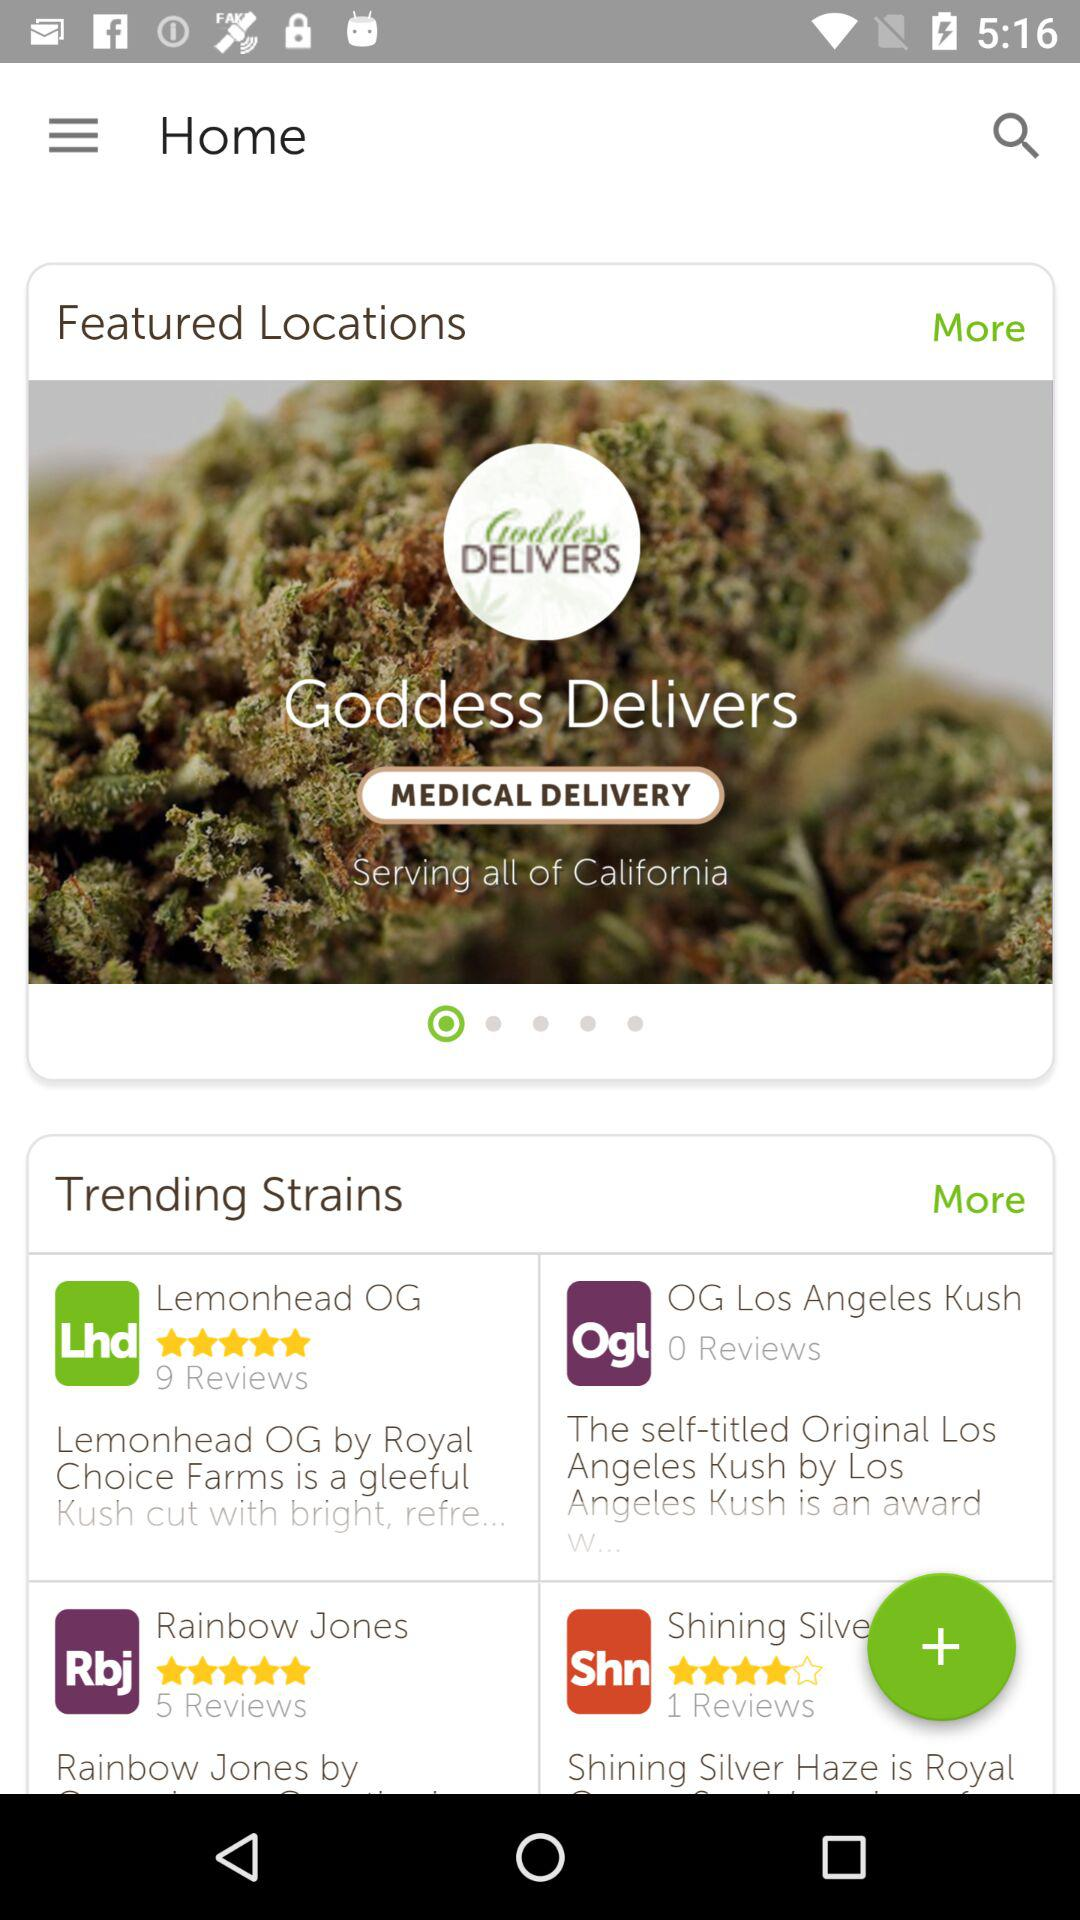How many more reviews does the first trending strain have than the second?
Answer the question using a single word or phrase. 9 